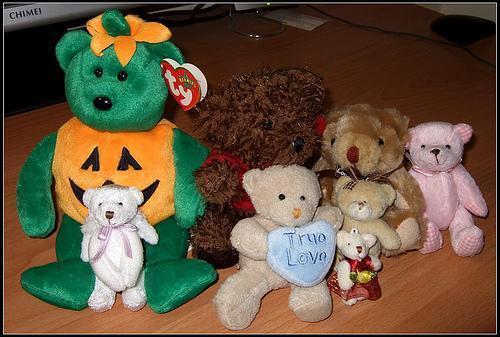How many bears are there?
Give a very brief answer. 8. How many teddy bears are visible?
Give a very brief answer. 8. How many people are sitting next to the tv?
Give a very brief answer. 0. 